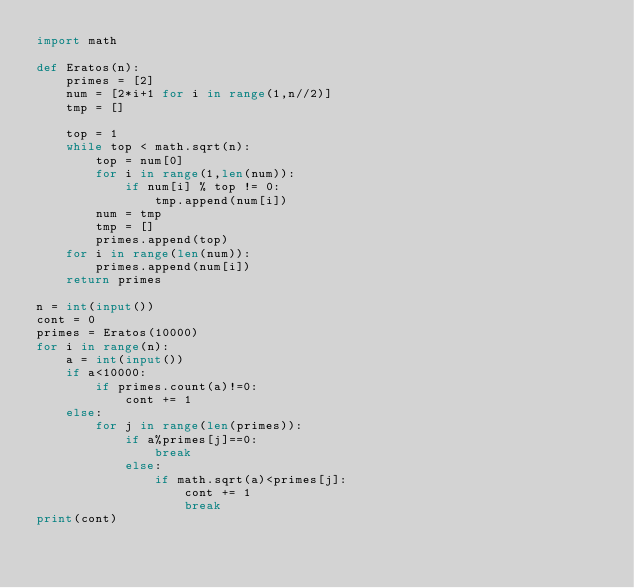Convert code to text. <code><loc_0><loc_0><loc_500><loc_500><_Python_>import math

def Eratos(n):
	primes = [2]
	num = [2*i+1 for i in range(1,n//2)]
	tmp = []

	top = 1
	while top < math.sqrt(n):
		top = num[0]
		for i in range(1,len(num)):
			if num[i] % top != 0:
				tmp.append(num[i])
		num = tmp
		tmp = []
		primes.append(top)
	for i in range(len(num)):
		primes.append(num[i])
	return primes

n = int(input())
cont = 0
primes = Eratos(10000)
for i in range(n):
	a = int(input())
	if a<10000:
		if primes.count(a)!=0:
			cont += 1
	else:
		for j in range(len(primes)):
			if a%primes[j]==0:
				break
			else:
				if math.sqrt(a)<primes[j]:
					cont += 1
					break
print(cont)
</code> 